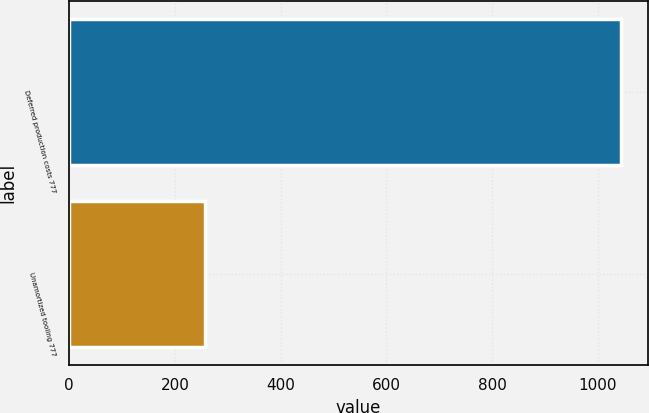Convert chart to OTSL. <chart><loc_0><loc_0><loc_500><loc_500><bar_chart><fcel>Deferred production costs 777<fcel>Unamortized tooling 777<nl><fcel>1043<fcel>256<nl></chart> 